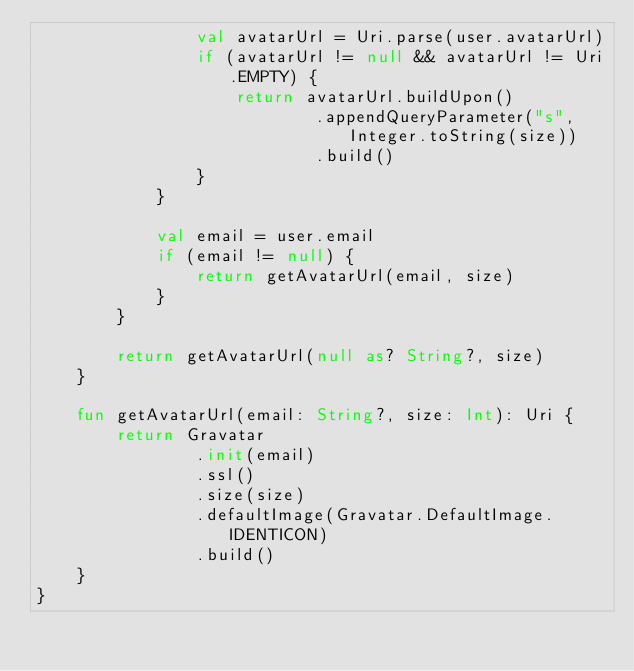<code> <loc_0><loc_0><loc_500><loc_500><_Kotlin_>                val avatarUrl = Uri.parse(user.avatarUrl)
                if (avatarUrl != null && avatarUrl != Uri.EMPTY) {
                    return avatarUrl.buildUpon()
                            .appendQueryParameter("s", Integer.toString(size))
                            .build()
                }
            }

            val email = user.email
            if (email != null) {
                return getAvatarUrl(email, size)
            }
        }

        return getAvatarUrl(null as? String?, size)
    }

    fun getAvatarUrl(email: String?, size: Int): Uri {
        return Gravatar
                .init(email)
                .ssl()
                .size(size)
                .defaultImage(Gravatar.DefaultImage.IDENTICON)
                .build()
    }
}
</code> 